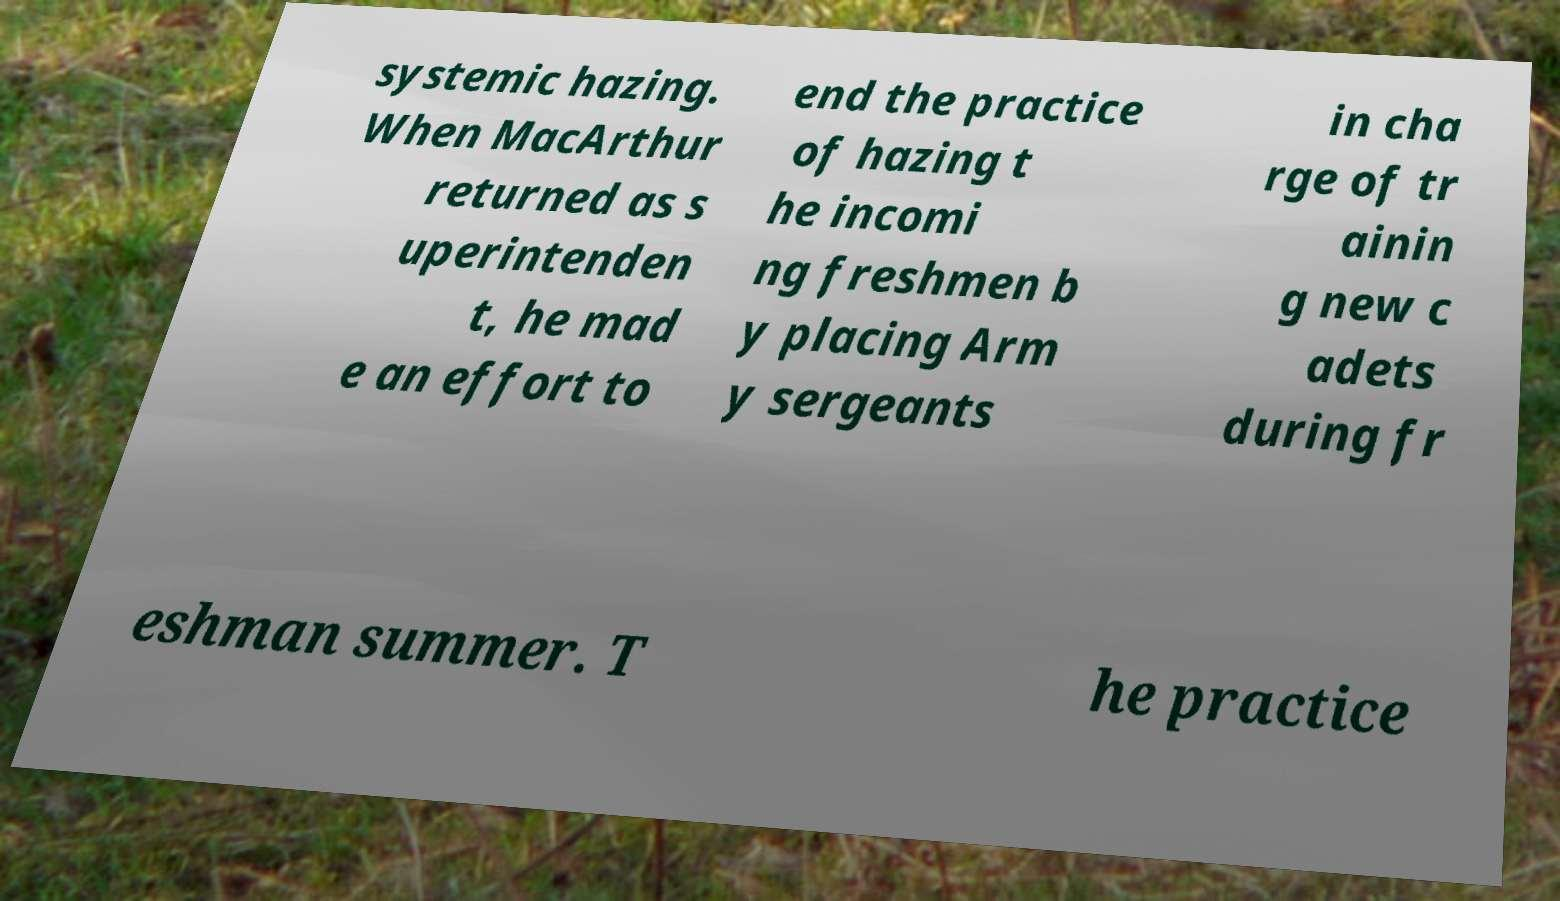Could you assist in decoding the text presented in this image and type it out clearly? systemic hazing. When MacArthur returned as s uperintenden t, he mad e an effort to end the practice of hazing t he incomi ng freshmen b y placing Arm y sergeants in cha rge of tr ainin g new c adets during fr eshman summer. T he practice 